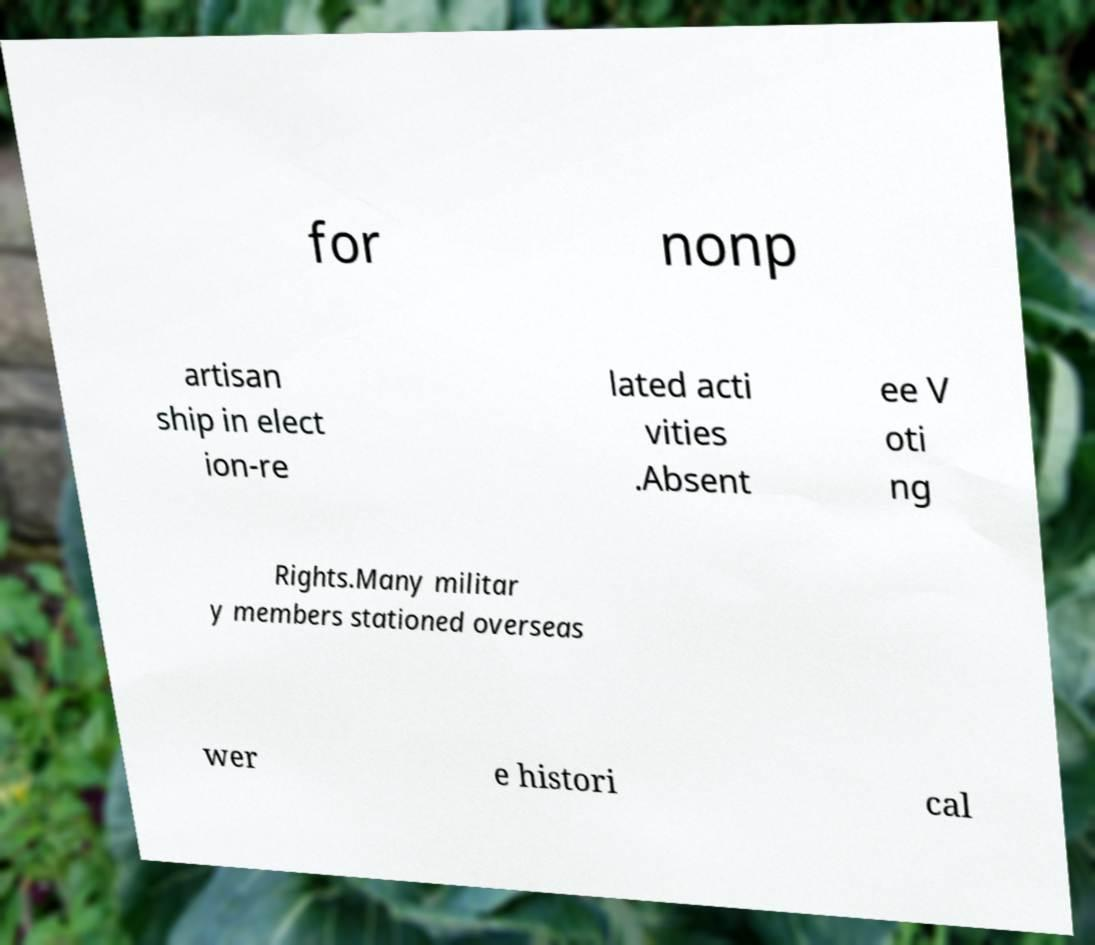Can you read and provide the text displayed in the image?This photo seems to have some interesting text. Can you extract and type it out for me? for nonp artisan ship in elect ion-re lated acti vities .Absent ee V oti ng Rights.Many militar y members stationed overseas wer e histori cal 